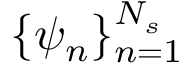Convert formula to latex. <formula><loc_0><loc_0><loc_500><loc_500>\{ \psi _ { n } \} _ { n = 1 } ^ { N _ { s } }</formula> 